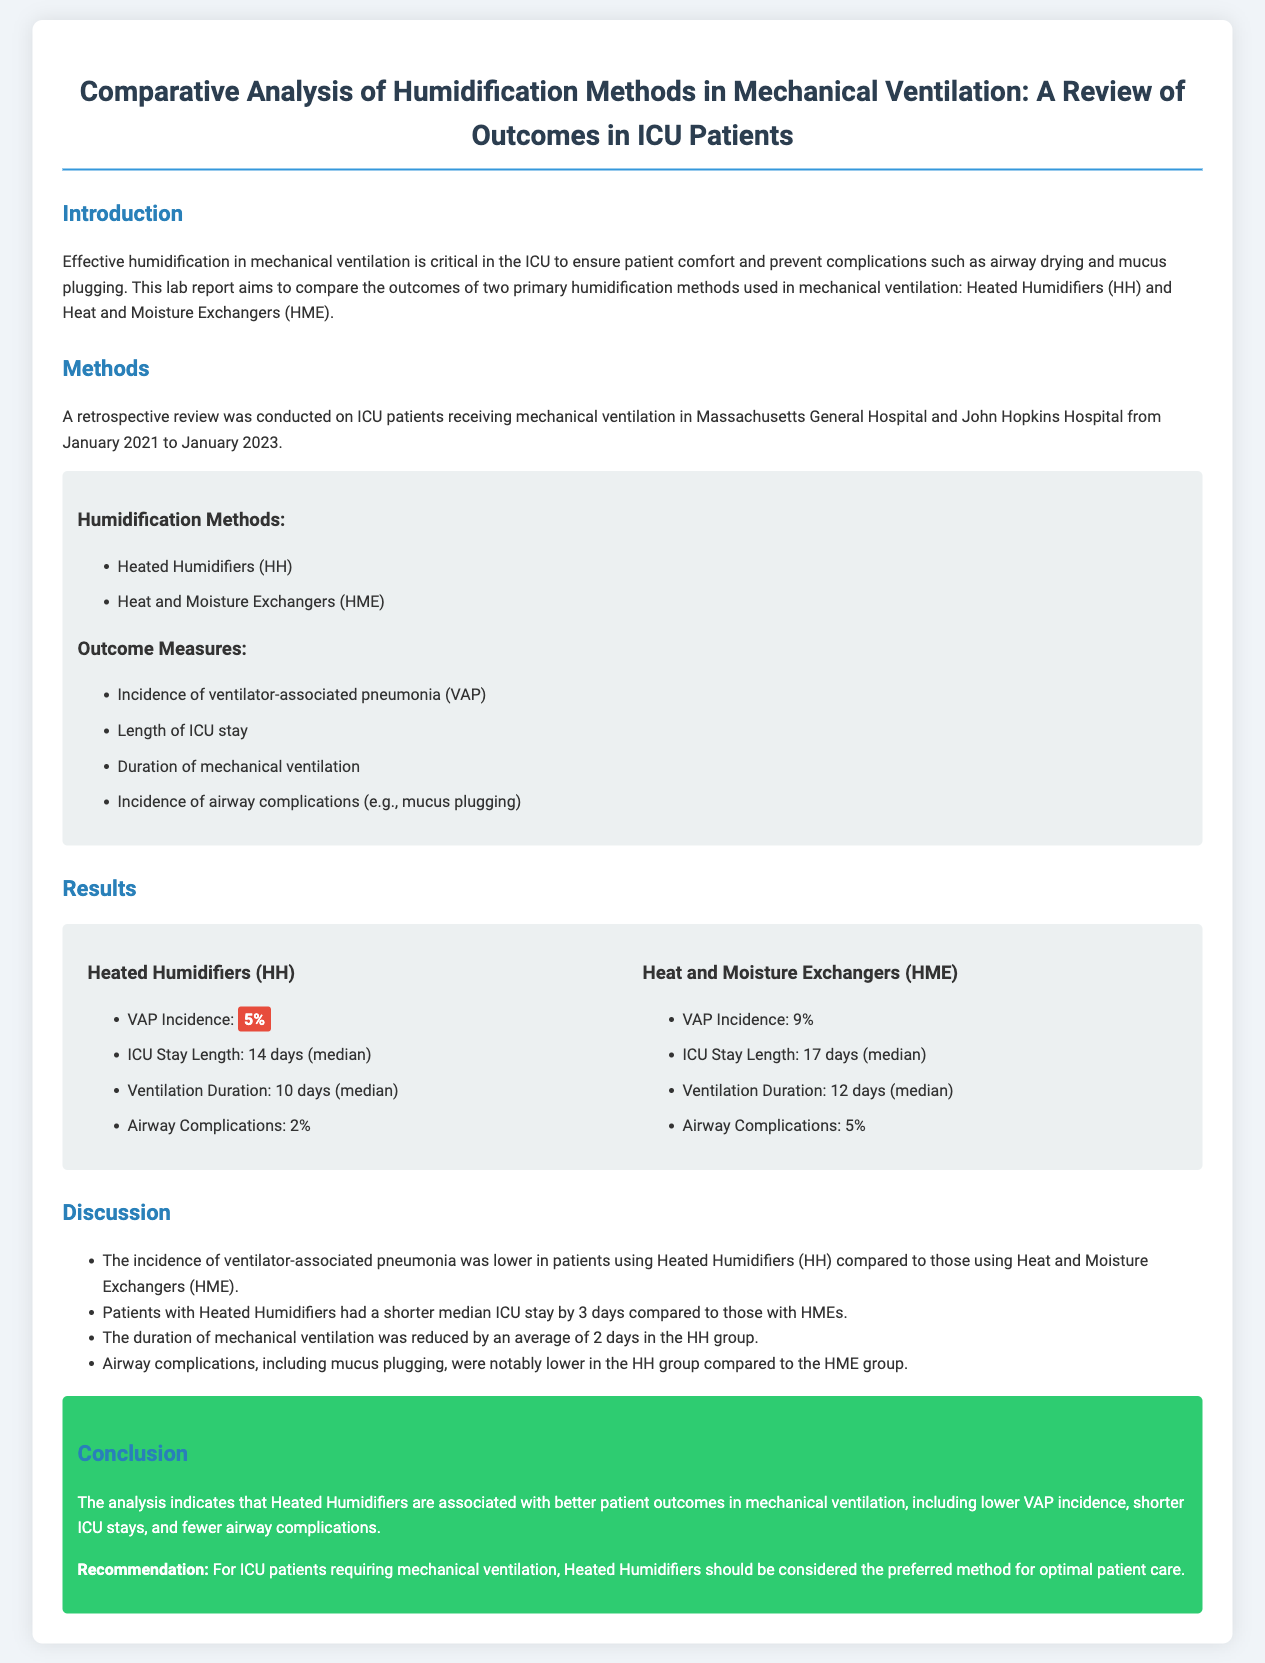What are the two primary humidification methods compared in this study? The document lists Heated Humidifiers (HH) and Heat and Moisture Exchangers (HME) as the two primary humidification methods in mechanical ventilation.
Answer: Heated Humidifiers (HH) and Heat and Moisture Exchangers (HME) What was the incidence of VAP for Heated Humidifiers (HH)? The document states the incidence of ventilator-associated pneumonia (VAP) for Heated Humidifiers (HH) is 5%.
Answer: 5% What was the median length of ICU stay for patients using HME? According to the document, the median length of ICU stay for patients using Heat and Moisture Exchangers (HME) is 17 days.
Answer: 17 days How much shorter was the ICU stay for patients with Heated Humidifiers compared to those with HMEs? The document indicates that patients with Heated Humidifiers had a shorter median ICU stay by 3 days compared to those with HMEs.
Answer: 3 days What is the recommendation for ICU patients requiring mechanical ventilation? The conclusion states that for ICU patients requiring mechanical ventilation, Heated Humidifiers should be considered the preferred method for optimal patient care.
Answer: Heated Humidifiers What is the median duration of mechanical ventilation for patients using HME? The report provides that the median duration of mechanical ventilation for patients using Heat and Moisture Exchangers (HME) is 12 days.
Answer: 12 days Which humidification method showed a lower incidence of airway complications? The document states that airway complications were notably lower in the Heated Humidifiers (HH) group compared to the HME group.
Answer: Heated Humidifiers (HH) What is the average reduction in the duration of mechanical ventilation in the HH group? The document indicates that the duration of mechanical ventilation was reduced by an average of 2 days in the Heated Humidifiers (HH) group.
Answer: 2 days What hospitals conducted the retrospective review for this study? The document mentions that the study was conducted at Massachusetts General Hospital and John Hopkins Hospital.
Answer: Massachusetts General Hospital and John Hopkins Hospital 